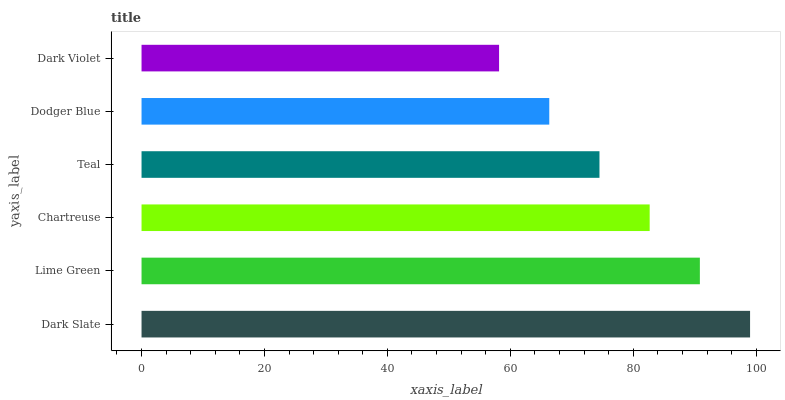Is Dark Violet the minimum?
Answer yes or no. Yes. Is Dark Slate the maximum?
Answer yes or no. Yes. Is Lime Green the minimum?
Answer yes or no. No. Is Lime Green the maximum?
Answer yes or no. No. Is Dark Slate greater than Lime Green?
Answer yes or no. Yes. Is Lime Green less than Dark Slate?
Answer yes or no. Yes. Is Lime Green greater than Dark Slate?
Answer yes or no. No. Is Dark Slate less than Lime Green?
Answer yes or no. No. Is Chartreuse the high median?
Answer yes or no. Yes. Is Teal the low median?
Answer yes or no. Yes. Is Dodger Blue the high median?
Answer yes or no. No. Is Chartreuse the low median?
Answer yes or no. No. 